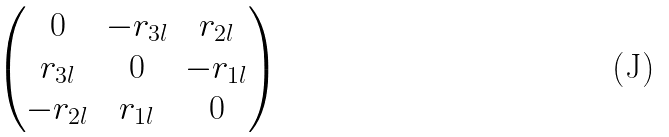<formula> <loc_0><loc_0><loc_500><loc_500>\begin{pmatrix} 0 & - r _ { 3 l } & r _ { 2 l } \\ r _ { 3 l } & 0 & - r _ { 1 l } \\ - r _ { 2 l } & r _ { 1 l } & 0 \end{pmatrix}</formula> 